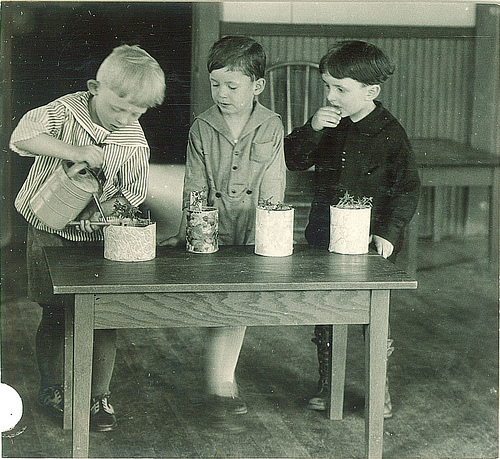<image>
Can you confirm if the wall is behind the child? Yes. From this viewpoint, the wall is positioned behind the child, with the child partially or fully occluding the wall. 